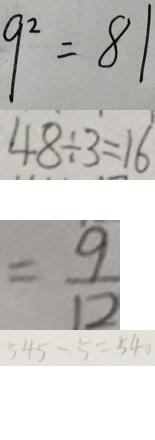<formula> <loc_0><loc_0><loc_500><loc_500>9 ^ { 2 } = 8 1 
 4 8 \div 3 = 1 6 
 = \frac { 9 } { 1 2 } 
 5 4 5 - 5 = 5 4 0</formula> 